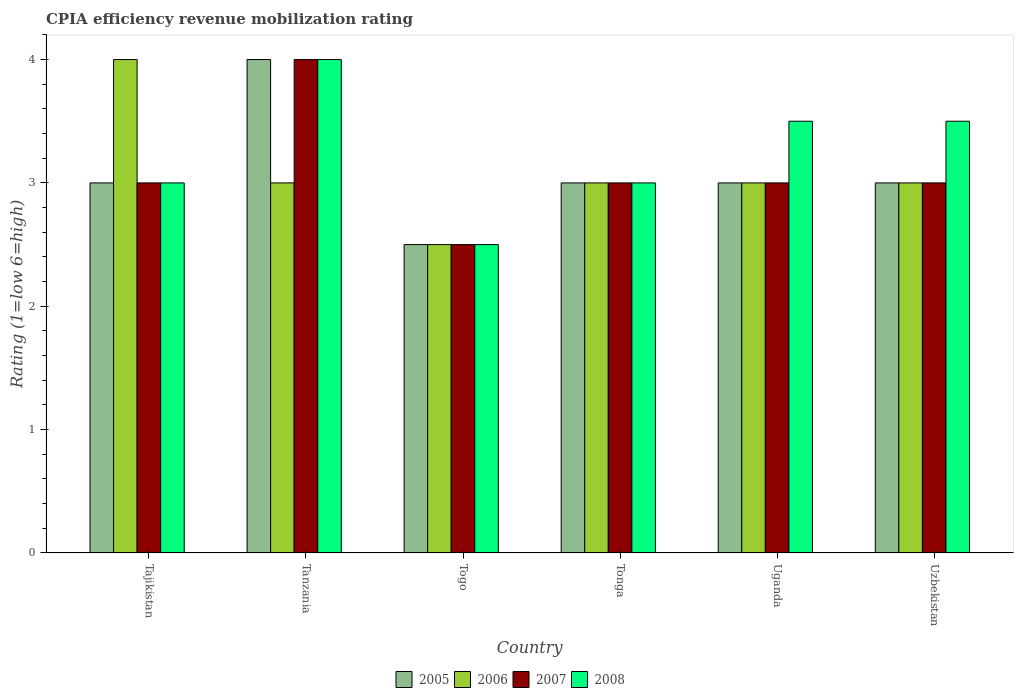How many different coloured bars are there?
Give a very brief answer. 4. Are the number of bars on each tick of the X-axis equal?
Your answer should be very brief. Yes. What is the label of the 3rd group of bars from the left?
Offer a very short reply. Togo. What is the CPIA rating in 2007 in Tajikistan?
Ensure brevity in your answer.  3. Across all countries, what is the maximum CPIA rating in 2007?
Offer a very short reply. 4. Across all countries, what is the minimum CPIA rating in 2007?
Ensure brevity in your answer.  2.5. In which country was the CPIA rating in 2005 maximum?
Keep it short and to the point. Tanzania. In which country was the CPIA rating in 2007 minimum?
Your response must be concise. Togo. What is the difference between the CPIA rating in 2007 in Tajikistan and that in Uzbekistan?
Make the answer very short. 0. What is the average CPIA rating in 2005 per country?
Offer a very short reply. 3.08. What is the difference between the CPIA rating of/in 2006 and CPIA rating of/in 2005 in Uzbekistan?
Provide a succinct answer. 0. In how many countries, is the CPIA rating in 2008 greater than 2.6?
Your answer should be compact. 5. Is it the case that in every country, the sum of the CPIA rating in 2005 and CPIA rating in 2008 is greater than the sum of CPIA rating in 2006 and CPIA rating in 2007?
Your answer should be very brief. No. What does the 4th bar from the left in Uganda represents?
Provide a short and direct response. 2008. How many countries are there in the graph?
Give a very brief answer. 6. What is the difference between two consecutive major ticks on the Y-axis?
Make the answer very short. 1. Where does the legend appear in the graph?
Give a very brief answer. Bottom center. How many legend labels are there?
Keep it short and to the point. 4. How are the legend labels stacked?
Keep it short and to the point. Horizontal. What is the title of the graph?
Make the answer very short. CPIA efficiency revenue mobilization rating. What is the label or title of the X-axis?
Your response must be concise. Country. What is the Rating (1=low 6=high) in 2005 in Tajikistan?
Offer a very short reply. 3. What is the Rating (1=low 6=high) of 2008 in Tajikistan?
Make the answer very short. 3. What is the Rating (1=low 6=high) of 2006 in Togo?
Your answer should be compact. 2.5. What is the Rating (1=low 6=high) of 2007 in Tonga?
Your answer should be compact. 3. What is the Rating (1=low 6=high) in 2008 in Tonga?
Your response must be concise. 3. What is the Rating (1=low 6=high) of 2007 in Uganda?
Provide a short and direct response. 3. What is the Rating (1=low 6=high) of 2005 in Uzbekistan?
Your answer should be compact. 3. What is the Rating (1=low 6=high) of 2006 in Uzbekistan?
Offer a terse response. 3. What is the Rating (1=low 6=high) in 2007 in Uzbekistan?
Keep it short and to the point. 3. What is the Rating (1=low 6=high) in 2008 in Uzbekistan?
Your answer should be very brief. 3.5. Across all countries, what is the maximum Rating (1=low 6=high) in 2006?
Provide a short and direct response. 4. Across all countries, what is the maximum Rating (1=low 6=high) in 2007?
Offer a very short reply. 4. Across all countries, what is the minimum Rating (1=low 6=high) of 2006?
Offer a terse response. 2.5. Across all countries, what is the minimum Rating (1=low 6=high) of 2007?
Your answer should be very brief. 2.5. What is the total Rating (1=low 6=high) of 2005 in the graph?
Your response must be concise. 18.5. What is the total Rating (1=low 6=high) of 2006 in the graph?
Your answer should be very brief. 18.5. What is the difference between the Rating (1=low 6=high) in 2008 in Tajikistan and that in Tanzania?
Provide a short and direct response. -1. What is the difference between the Rating (1=low 6=high) in 2008 in Tajikistan and that in Togo?
Your answer should be very brief. 0.5. What is the difference between the Rating (1=low 6=high) in 2005 in Tajikistan and that in Tonga?
Your answer should be compact. 0. What is the difference between the Rating (1=low 6=high) in 2006 in Tajikistan and that in Tonga?
Your answer should be compact. 1. What is the difference between the Rating (1=low 6=high) in 2007 in Tajikistan and that in Tonga?
Give a very brief answer. 0. What is the difference between the Rating (1=low 6=high) of 2005 in Tajikistan and that in Uganda?
Provide a succinct answer. 0. What is the difference between the Rating (1=low 6=high) in 2005 in Tajikistan and that in Uzbekistan?
Your answer should be compact. 0. What is the difference between the Rating (1=low 6=high) in 2007 in Tajikistan and that in Uzbekistan?
Your response must be concise. 0. What is the difference between the Rating (1=low 6=high) in 2005 in Tanzania and that in Togo?
Your answer should be compact. 1.5. What is the difference between the Rating (1=low 6=high) of 2006 in Tanzania and that in Togo?
Ensure brevity in your answer.  0.5. What is the difference between the Rating (1=low 6=high) of 2006 in Tanzania and that in Tonga?
Give a very brief answer. 0. What is the difference between the Rating (1=low 6=high) of 2008 in Tanzania and that in Tonga?
Your answer should be very brief. 1. What is the difference between the Rating (1=low 6=high) of 2005 in Tanzania and that in Uganda?
Your answer should be very brief. 1. What is the difference between the Rating (1=low 6=high) of 2007 in Tanzania and that in Uganda?
Keep it short and to the point. 1. What is the difference between the Rating (1=low 6=high) of 2008 in Tanzania and that in Uganda?
Provide a succinct answer. 0.5. What is the difference between the Rating (1=low 6=high) in 2005 in Togo and that in Tonga?
Provide a short and direct response. -0.5. What is the difference between the Rating (1=low 6=high) in 2007 in Togo and that in Tonga?
Keep it short and to the point. -0.5. What is the difference between the Rating (1=low 6=high) of 2005 in Togo and that in Uganda?
Your answer should be very brief. -0.5. What is the difference between the Rating (1=low 6=high) of 2006 in Togo and that in Uganda?
Keep it short and to the point. -0.5. What is the difference between the Rating (1=low 6=high) in 2008 in Togo and that in Uganda?
Offer a terse response. -1. What is the difference between the Rating (1=low 6=high) in 2005 in Tonga and that in Uganda?
Offer a terse response. 0. What is the difference between the Rating (1=low 6=high) of 2007 in Tonga and that in Uganda?
Your answer should be very brief. 0. What is the difference between the Rating (1=low 6=high) of 2006 in Tonga and that in Uzbekistan?
Keep it short and to the point. 0. What is the difference between the Rating (1=low 6=high) in 2007 in Tonga and that in Uzbekistan?
Offer a terse response. 0. What is the difference between the Rating (1=low 6=high) in 2008 in Tonga and that in Uzbekistan?
Offer a terse response. -0.5. What is the difference between the Rating (1=low 6=high) in 2006 in Uganda and that in Uzbekistan?
Keep it short and to the point. 0. What is the difference between the Rating (1=low 6=high) of 2006 in Tajikistan and the Rating (1=low 6=high) of 2007 in Tanzania?
Keep it short and to the point. 0. What is the difference between the Rating (1=low 6=high) of 2005 in Tajikistan and the Rating (1=low 6=high) of 2006 in Togo?
Provide a short and direct response. 0.5. What is the difference between the Rating (1=low 6=high) of 2005 in Tajikistan and the Rating (1=low 6=high) of 2007 in Togo?
Offer a terse response. 0.5. What is the difference between the Rating (1=low 6=high) of 2005 in Tajikistan and the Rating (1=low 6=high) of 2008 in Togo?
Your response must be concise. 0.5. What is the difference between the Rating (1=low 6=high) of 2006 in Tajikistan and the Rating (1=low 6=high) of 2007 in Togo?
Provide a succinct answer. 1.5. What is the difference between the Rating (1=low 6=high) in 2006 in Tajikistan and the Rating (1=low 6=high) in 2008 in Togo?
Offer a terse response. 1.5. What is the difference between the Rating (1=low 6=high) in 2005 in Tajikistan and the Rating (1=low 6=high) in 2006 in Tonga?
Your answer should be very brief. 0. What is the difference between the Rating (1=low 6=high) of 2006 in Tajikistan and the Rating (1=low 6=high) of 2007 in Tonga?
Keep it short and to the point. 1. What is the difference between the Rating (1=low 6=high) in 2006 in Tajikistan and the Rating (1=low 6=high) in 2008 in Tonga?
Offer a terse response. 1. What is the difference between the Rating (1=low 6=high) in 2007 in Tajikistan and the Rating (1=low 6=high) in 2008 in Tonga?
Offer a terse response. 0. What is the difference between the Rating (1=low 6=high) in 2005 in Tajikistan and the Rating (1=low 6=high) in 2007 in Uganda?
Your answer should be compact. 0. What is the difference between the Rating (1=low 6=high) of 2005 in Tajikistan and the Rating (1=low 6=high) of 2008 in Uganda?
Offer a terse response. -0.5. What is the difference between the Rating (1=low 6=high) of 2006 in Tajikistan and the Rating (1=low 6=high) of 2007 in Uganda?
Make the answer very short. 1. What is the difference between the Rating (1=low 6=high) in 2006 in Tajikistan and the Rating (1=low 6=high) in 2008 in Uganda?
Keep it short and to the point. 0.5. What is the difference between the Rating (1=low 6=high) in 2007 in Tajikistan and the Rating (1=low 6=high) in 2008 in Uganda?
Offer a terse response. -0.5. What is the difference between the Rating (1=low 6=high) in 2005 in Tajikistan and the Rating (1=low 6=high) in 2006 in Uzbekistan?
Offer a very short reply. 0. What is the difference between the Rating (1=low 6=high) of 2005 in Tajikistan and the Rating (1=low 6=high) of 2007 in Uzbekistan?
Offer a terse response. 0. What is the difference between the Rating (1=low 6=high) of 2005 in Tanzania and the Rating (1=low 6=high) of 2006 in Togo?
Offer a very short reply. 1.5. What is the difference between the Rating (1=low 6=high) in 2005 in Tanzania and the Rating (1=low 6=high) in 2007 in Togo?
Offer a terse response. 1.5. What is the difference between the Rating (1=low 6=high) of 2006 in Tanzania and the Rating (1=low 6=high) of 2007 in Togo?
Keep it short and to the point. 0.5. What is the difference between the Rating (1=low 6=high) of 2005 in Tanzania and the Rating (1=low 6=high) of 2007 in Tonga?
Keep it short and to the point. 1. What is the difference between the Rating (1=low 6=high) of 2006 in Tanzania and the Rating (1=low 6=high) of 2007 in Tonga?
Your response must be concise. 0. What is the difference between the Rating (1=low 6=high) of 2006 in Tanzania and the Rating (1=low 6=high) of 2008 in Tonga?
Give a very brief answer. 0. What is the difference between the Rating (1=low 6=high) of 2007 in Tanzania and the Rating (1=low 6=high) of 2008 in Tonga?
Your response must be concise. 1. What is the difference between the Rating (1=low 6=high) in 2005 in Tanzania and the Rating (1=low 6=high) in 2008 in Uganda?
Your answer should be very brief. 0.5. What is the difference between the Rating (1=low 6=high) in 2006 in Tanzania and the Rating (1=low 6=high) in 2008 in Uganda?
Make the answer very short. -0.5. What is the difference between the Rating (1=low 6=high) in 2007 in Tanzania and the Rating (1=low 6=high) in 2008 in Uganda?
Ensure brevity in your answer.  0.5. What is the difference between the Rating (1=low 6=high) in 2005 in Togo and the Rating (1=low 6=high) in 2006 in Tonga?
Your answer should be very brief. -0.5. What is the difference between the Rating (1=low 6=high) of 2005 in Togo and the Rating (1=low 6=high) of 2007 in Tonga?
Your answer should be very brief. -0.5. What is the difference between the Rating (1=low 6=high) of 2005 in Togo and the Rating (1=low 6=high) of 2008 in Tonga?
Provide a short and direct response. -0.5. What is the difference between the Rating (1=low 6=high) of 2006 in Togo and the Rating (1=low 6=high) of 2007 in Tonga?
Provide a short and direct response. -0.5. What is the difference between the Rating (1=low 6=high) in 2006 in Togo and the Rating (1=low 6=high) in 2008 in Tonga?
Your answer should be compact. -0.5. What is the difference between the Rating (1=low 6=high) of 2005 in Togo and the Rating (1=low 6=high) of 2006 in Uganda?
Make the answer very short. -0.5. What is the difference between the Rating (1=low 6=high) in 2005 in Togo and the Rating (1=low 6=high) in 2008 in Uganda?
Keep it short and to the point. -1. What is the difference between the Rating (1=low 6=high) in 2006 in Togo and the Rating (1=low 6=high) in 2007 in Uganda?
Give a very brief answer. -0.5. What is the difference between the Rating (1=low 6=high) in 2006 in Togo and the Rating (1=low 6=high) in 2008 in Uganda?
Offer a terse response. -1. What is the difference between the Rating (1=low 6=high) of 2007 in Togo and the Rating (1=low 6=high) of 2008 in Uganda?
Ensure brevity in your answer.  -1. What is the difference between the Rating (1=low 6=high) of 2005 in Togo and the Rating (1=low 6=high) of 2008 in Uzbekistan?
Keep it short and to the point. -1. What is the difference between the Rating (1=low 6=high) of 2006 in Togo and the Rating (1=low 6=high) of 2007 in Uzbekistan?
Give a very brief answer. -0.5. What is the difference between the Rating (1=low 6=high) in 2006 in Togo and the Rating (1=low 6=high) in 2008 in Uzbekistan?
Offer a terse response. -1. What is the difference between the Rating (1=low 6=high) of 2007 in Togo and the Rating (1=low 6=high) of 2008 in Uzbekistan?
Ensure brevity in your answer.  -1. What is the difference between the Rating (1=low 6=high) in 2005 in Tonga and the Rating (1=low 6=high) in 2007 in Uganda?
Offer a terse response. 0. What is the difference between the Rating (1=low 6=high) in 2007 in Tonga and the Rating (1=low 6=high) in 2008 in Uganda?
Provide a succinct answer. -0.5. What is the difference between the Rating (1=low 6=high) in 2005 in Tonga and the Rating (1=low 6=high) in 2007 in Uzbekistan?
Ensure brevity in your answer.  0. What is the difference between the Rating (1=low 6=high) in 2007 in Tonga and the Rating (1=low 6=high) in 2008 in Uzbekistan?
Your answer should be very brief. -0.5. What is the difference between the Rating (1=low 6=high) of 2005 in Uganda and the Rating (1=low 6=high) of 2006 in Uzbekistan?
Offer a terse response. 0. What is the difference between the Rating (1=low 6=high) of 2005 in Uganda and the Rating (1=low 6=high) of 2007 in Uzbekistan?
Your response must be concise. 0. What is the difference between the Rating (1=low 6=high) in 2006 in Uganda and the Rating (1=low 6=high) in 2007 in Uzbekistan?
Your answer should be very brief. 0. What is the average Rating (1=low 6=high) of 2005 per country?
Keep it short and to the point. 3.08. What is the average Rating (1=low 6=high) of 2006 per country?
Give a very brief answer. 3.08. What is the average Rating (1=low 6=high) of 2007 per country?
Give a very brief answer. 3.08. What is the difference between the Rating (1=low 6=high) in 2005 and Rating (1=low 6=high) in 2006 in Tajikistan?
Ensure brevity in your answer.  -1. What is the difference between the Rating (1=low 6=high) in 2005 and Rating (1=low 6=high) in 2007 in Tajikistan?
Keep it short and to the point. 0. What is the difference between the Rating (1=low 6=high) of 2006 and Rating (1=low 6=high) of 2008 in Tajikistan?
Ensure brevity in your answer.  1. What is the difference between the Rating (1=low 6=high) in 2007 and Rating (1=low 6=high) in 2008 in Tajikistan?
Make the answer very short. 0. What is the difference between the Rating (1=low 6=high) of 2005 and Rating (1=low 6=high) of 2008 in Tanzania?
Offer a terse response. 0. What is the difference between the Rating (1=low 6=high) of 2006 and Rating (1=low 6=high) of 2008 in Tanzania?
Keep it short and to the point. -1. What is the difference between the Rating (1=low 6=high) of 2005 and Rating (1=low 6=high) of 2007 in Togo?
Offer a very short reply. 0. What is the difference between the Rating (1=low 6=high) of 2006 and Rating (1=low 6=high) of 2007 in Togo?
Provide a short and direct response. 0. What is the difference between the Rating (1=low 6=high) in 2006 and Rating (1=low 6=high) in 2008 in Togo?
Your answer should be compact. 0. What is the difference between the Rating (1=low 6=high) in 2005 and Rating (1=low 6=high) in 2006 in Tonga?
Make the answer very short. 0. What is the difference between the Rating (1=low 6=high) in 2005 and Rating (1=low 6=high) in 2008 in Tonga?
Provide a short and direct response. 0. What is the difference between the Rating (1=low 6=high) in 2006 and Rating (1=low 6=high) in 2007 in Tonga?
Make the answer very short. 0. What is the difference between the Rating (1=low 6=high) of 2006 and Rating (1=low 6=high) of 2008 in Tonga?
Offer a very short reply. 0. What is the difference between the Rating (1=low 6=high) of 2007 and Rating (1=low 6=high) of 2008 in Tonga?
Your response must be concise. 0. What is the difference between the Rating (1=low 6=high) of 2005 and Rating (1=low 6=high) of 2006 in Uganda?
Your response must be concise. 0. What is the difference between the Rating (1=low 6=high) of 2005 and Rating (1=low 6=high) of 2007 in Uganda?
Give a very brief answer. 0. What is the difference between the Rating (1=low 6=high) in 2005 and Rating (1=low 6=high) in 2008 in Uganda?
Give a very brief answer. -0.5. What is the difference between the Rating (1=low 6=high) in 2006 and Rating (1=low 6=high) in 2008 in Uganda?
Provide a short and direct response. -0.5. What is the difference between the Rating (1=low 6=high) of 2005 and Rating (1=low 6=high) of 2006 in Uzbekistan?
Your answer should be very brief. 0. What is the difference between the Rating (1=low 6=high) in 2005 and Rating (1=low 6=high) in 2007 in Uzbekistan?
Offer a terse response. 0. What is the difference between the Rating (1=low 6=high) in 2005 and Rating (1=low 6=high) in 2008 in Uzbekistan?
Offer a terse response. -0.5. What is the difference between the Rating (1=low 6=high) in 2006 and Rating (1=low 6=high) in 2007 in Uzbekistan?
Offer a terse response. 0. What is the difference between the Rating (1=low 6=high) of 2007 and Rating (1=low 6=high) of 2008 in Uzbekistan?
Offer a very short reply. -0.5. What is the ratio of the Rating (1=low 6=high) of 2007 in Tajikistan to that in Togo?
Give a very brief answer. 1.2. What is the ratio of the Rating (1=low 6=high) in 2008 in Tajikistan to that in Togo?
Your response must be concise. 1.2. What is the ratio of the Rating (1=low 6=high) of 2006 in Tajikistan to that in Tonga?
Provide a succinct answer. 1.33. What is the ratio of the Rating (1=low 6=high) of 2008 in Tajikistan to that in Tonga?
Provide a succinct answer. 1. What is the ratio of the Rating (1=low 6=high) of 2006 in Tajikistan to that in Uganda?
Your response must be concise. 1.33. What is the ratio of the Rating (1=low 6=high) in 2007 in Tajikistan to that in Uganda?
Give a very brief answer. 1. What is the ratio of the Rating (1=low 6=high) in 2008 in Tajikistan to that in Uganda?
Make the answer very short. 0.86. What is the ratio of the Rating (1=low 6=high) in 2008 in Tajikistan to that in Uzbekistan?
Provide a succinct answer. 0.86. What is the ratio of the Rating (1=low 6=high) in 2005 in Tanzania to that in Togo?
Offer a very short reply. 1.6. What is the ratio of the Rating (1=low 6=high) in 2005 in Tanzania to that in Tonga?
Provide a short and direct response. 1.33. What is the ratio of the Rating (1=low 6=high) of 2008 in Tanzania to that in Tonga?
Keep it short and to the point. 1.33. What is the ratio of the Rating (1=low 6=high) of 2005 in Tanzania to that in Uganda?
Your response must be concise. 1.33. What is the ratio of the Rating (1=low 6=high) of 2007 in Tanzania to that in Uganda?
Give a very brief answer. 1.33. What is the ratio of the Rating (1=low 6=high) in 2008 in Tanzania to that in Uganda?
Give a very brief answer. 1.14. What is the ratio of the Rating (1=low 6=high) of 2006 in Togo to that in Tonga?
Make the answer very short. 0.83. What is the ratio of the Rating (1=low 6=high) in 2007 in Togo to that in Tonga?
Provide a succinct answer. 0.83. What is the ratio of the Rating (1=low 6=high) of 2008 in Togo to that in Tonga?
Provide a short and direct response. 0.83. What is the ratio of the Rating (1=low 6=high) in 2005 in Togo to that in Uganda?
Offer a terse response. 0.83. What is the ratio of the Rating (1=low 6=high) in 2008 in Togo to that in Uganda?
Offer a terse response. 0.71. What is the ratio of the Rating (1=low 6=high) of 2007 in Togo to that in Uzbekistan?
Keep it short and to the point. 0.83. What is the ratio of the Rating (1=low 6=high) in 2007 in Tonga to that in Uganda?
Provide a short and direct response. 1. What is the ratio of the Rating (1=low 6=high) of 2008 in Tonga to that in Uganda?
Your response must be concise. 0.86. What is the ratio of the Rating (1=low 6=high) in 2006 in Tonga to that in Uzbekistan?
Make the answer very short. 1. What is the ratio of the Rating (1=low 6=high) of 2007 in Tonga to that in Uzbekistan?
Give a very brief answer. 1. What is the ratio of the Rating (1=low 6=high) of 2005 in Uganda to that in Uzbekistan?
Your answer should be compact. 1. What is the ratio of the Rating (1=low 6=high) in 2007 in Uganda to that in Uzbekistan?
Offer a terse response. 1. What is the ratio of the Rating (1=low 6=high) in 2008 in Uganda to that in Uzbekistan?
Your answer should be compact. 1. What is the difference between the highest and the second highest Rating (1=low 6=high) in 2007?
Your answer should be very brief. 1. What is the difference between the highest and the second highest Rating (1=low 6=high) in 2008?
Offer a very short reply. 0.5. What is the difference between the highest and the lowest Rating (1=low 6=high) in 2007?
Offer a very short reply. 1.5. 